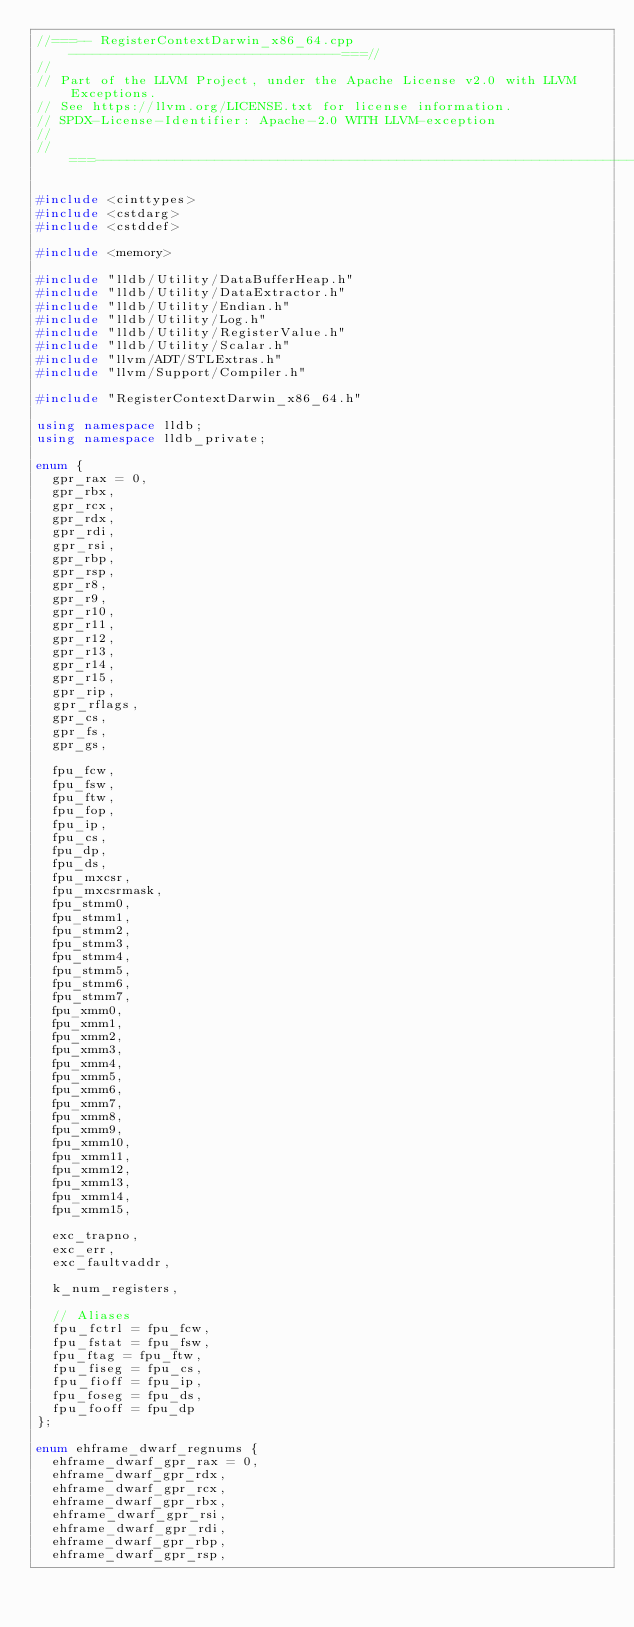<code> <loc_0><loc_0><loc_500><loc_500><_C++_>//===-- RegisterContextDarwin_x86_64.cpp ----------------------------------===//
//
// Part of the LLVM Project, under the Apache License v2.0 with LLVM Exceptions.
// See https://llvm.org/LICENSE.txt for license information.
// SPDX-License-Identifier: Apache-2.0 WITH LLVM-exception
//
//===----------------------------------------------------------------------===//

#include <cinttypes>
#include <cstdarg>
#include <cstddef>

#include <memory>

#include "lldb/Utility/DataBufferHeap.h"
#include "lldb/Utility/DataExtractor.h"
#include "lldb/Utility/Endian.h"
#include "lldb/Utility/Log.h"
#include "lldb/Utility/RegisterValue.h"
#include "lldb/Utility/Scalar.h"
#include "llvm/ADT/STLExtras.h"
#include "llvm/Support/Compiler.h"

#include "RegisterContextDarwin_x86_64.h"

using namespace lldb;
using namespace lldb_private;

enum {
  gpr_rax = 0,
  gpr_rbx,
  gpr_rcx,
  gpr_rdx,
  gpr_rdi,
  gpr_rsi,
  gpr_rbp,
  gpr_rsp,
  gpr_r8,
  gpr_r9,
  gpr_r10,
  gpr_r11,
  gpr_r12,
  gpr_r13,
  gpr_r14,
  gpr_r15,
  gpr_rip,
  gpr_rflags,
  gpr_cs,
  gpr_fs,
  gpr_gs,

  fpu_fcw,
  fpu_fsw,
  fpu_ftw,
  fpu_fop,
  fpu_ip,
  fpu_cs,
  fpu_dp,
  fpu_ds,
  fpu_mxcsr,
  fpu_mxcsrmask,
  fpu_stmm0,
  fpu_stmm1,
  fpu_stmm2,
  fpu_stmm3,
  fpu_stmm4,
  fpu_stmm5,
  fpu_stmm6,
  fpu_stmm7,
  fpu_xmm0,
  fpu_xmm1,
  fpu_xmm2,
  fpu_xmm3,
  fpu_xmm4,
  fpu_xmm5,
  fpu_xmm6,
  fpu_xmm7,
  fpu_xmm8,
  fpu_xmm9,
  fpu_xmm10,
  fpu_xmm11,
  fpu_xmm12,
  fpu_xmm13,
  fpu_xmm14,
  fpu_xmm15,

  exc_trapno,
  exc_err,
  exc_faultvaddr,

  k_num_registers,

  // Aliases
  fpu_fctrl = fpu_fcw,
  fpu_fstat = fpu_fsw,
  fpu_ftag = fpu_ftw,
  fpu_fiseg = fpu_cs,
  fpu_fioff = fpu_ip,
  fpu_foseg = fpu_ds,
  fpu_fooff = fpu_dp
};

enum ehframe_dwarf_regnums {
  ehframe_dwarf_gpr_rax = 0,
  ehframe_dwarf_gpr_rdx,
  ehframe_dwarf_gpr_rcx,
  ehframe_dwarf_gpr_rbx,
  ehframe_dwarf_gpr_rsi,
  ehframe_dwarf_gpr_rdi,
  ehframe_dwarf_gpr_rbp,
  ehframe_dwarf_gpr_rsp,</code> 